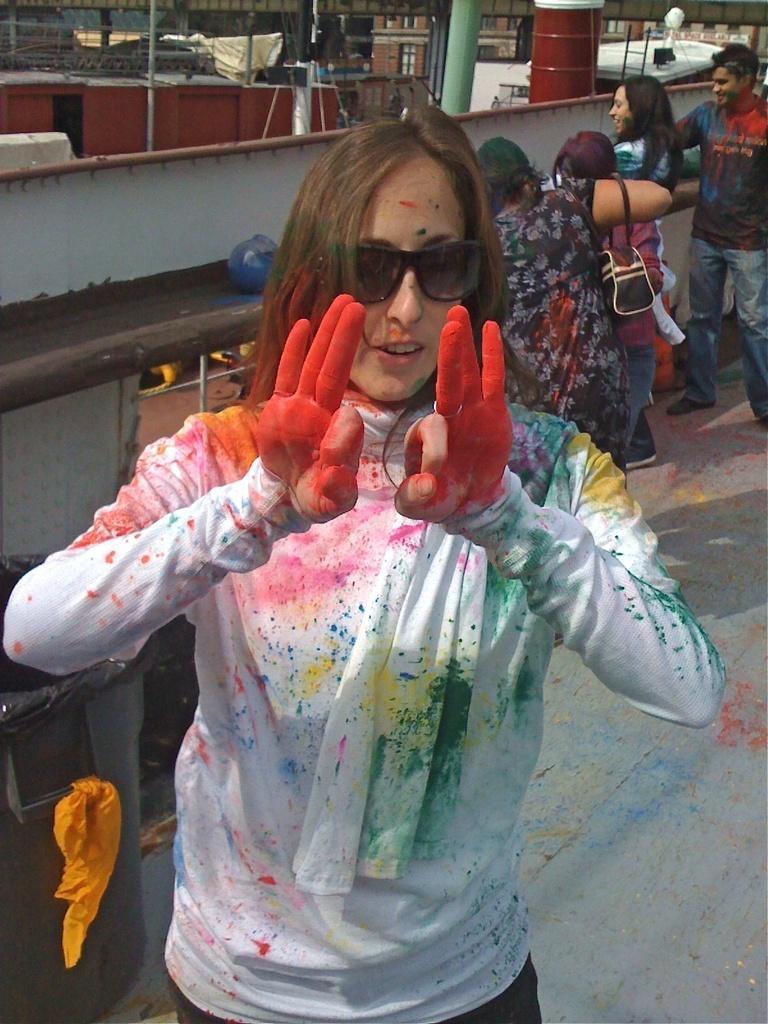How would you summarize this image in a sentence or two? In this picture I can observe a woman wearing white color dress. There are some colors on her dress. I can observe red, green, yellow and pink colors on her dress. She is wearing spectacles. In the background there are some people standing on the land. 